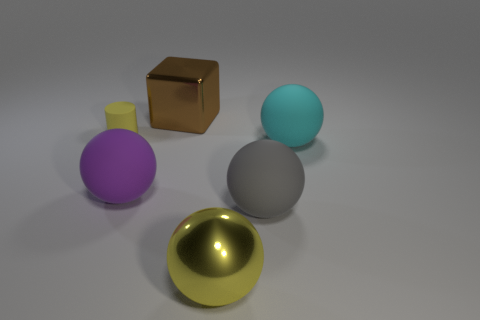Add 1 purple things. How many objects exist? 7 Subtract all cubes. How many objects are left? 5 Add 2 yellow rubber objects. How many yellow rubber objects exist? 3 Subtract 0 green cubes. How many objects are left? 6 Subtract all yellow rubber cylinders. Subtract all purple matte cylinders. How many objects are left? 5 Add 4 cyan rubber spheres. How many cyan rubber spheres are left? 5 